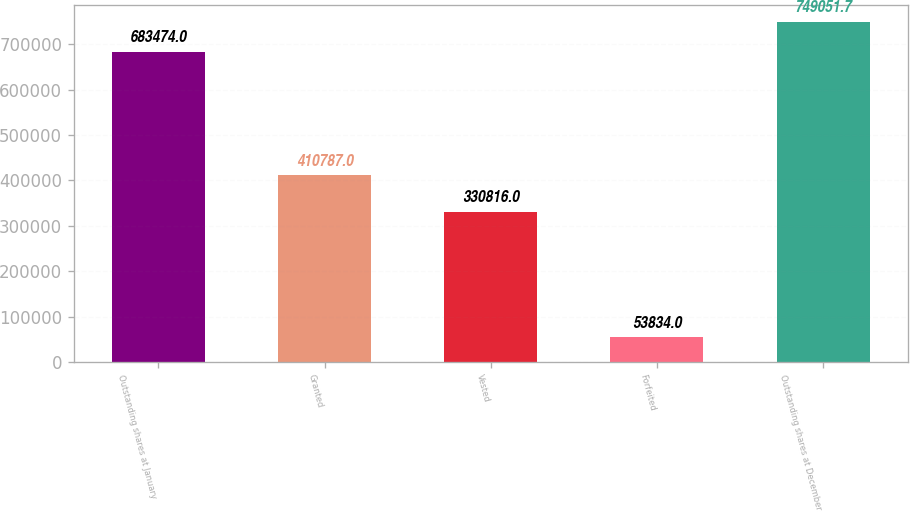Convert chart to OTSL. <chart><loc_0><loc_0><loc_500><loc_500><bar_chart><fcel>Outstanding shares at January<fcel>Granted<fcel>Vested<fcel>Forfeited<fcel>Outstanding shares at December<nl><fcel>683474<fcel>410787<fcel>330816<fcel>53834<fcel>749052<nl></chart> 